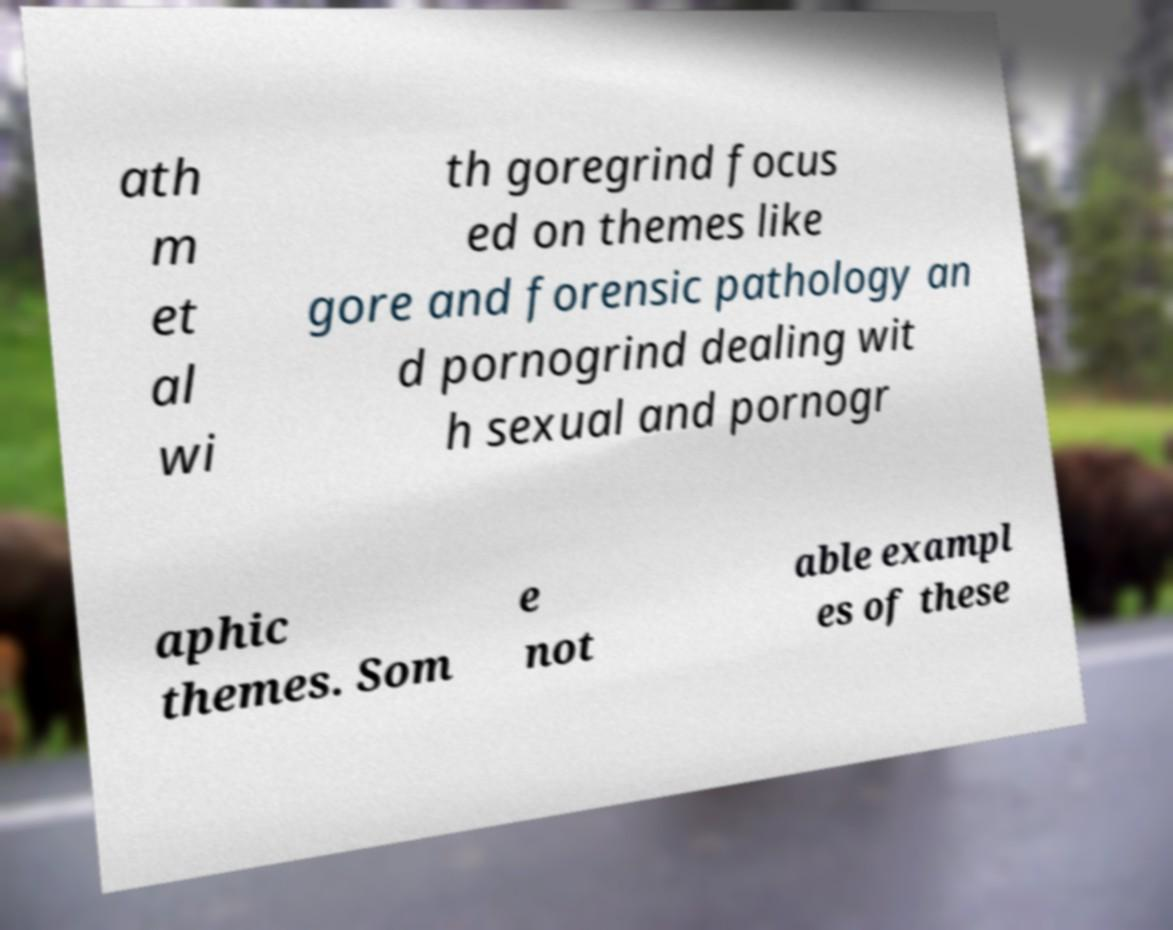What messages or text are displayed in this image? I need them in a readable, typed format. ath m et al wi th goregrind focus ed on themes like gore and forensic pathology an d pornogrind dealing wit h sexual and pornogr aphic themes. Som e not able exampl es of these 